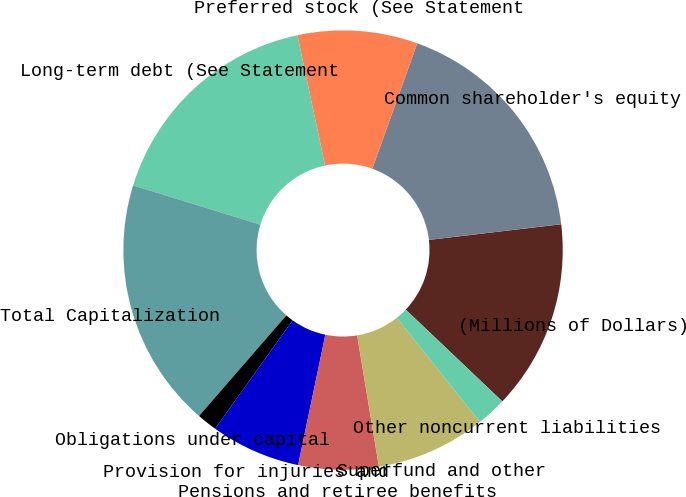Convert chart. <chart><loc_0><loc_0><loc_500><loc_500><pie_chart><fcel>(Millions of Dollars)<fcel>Common shareholder's equity<fcel>Preferred stock (See Statement<fcel>Long-term debt (See Statement<fcel>Total Capitalization<fcel>Obligations under capital<fcel>Provision for injuries and<fcel>Pensions and retiree benefits<fcel>Superfund and other<fcel>Other noncurrent liabilities<nl><fcel>13.97%<fcel>17.64%<fcel>8.82%<fcel>16.91%<fcel>18.38%<fcel>1.48%<fcel>6.62%<fcel>5.89%<fcel>8.09%<fcel>2.21%<nl></chart> 